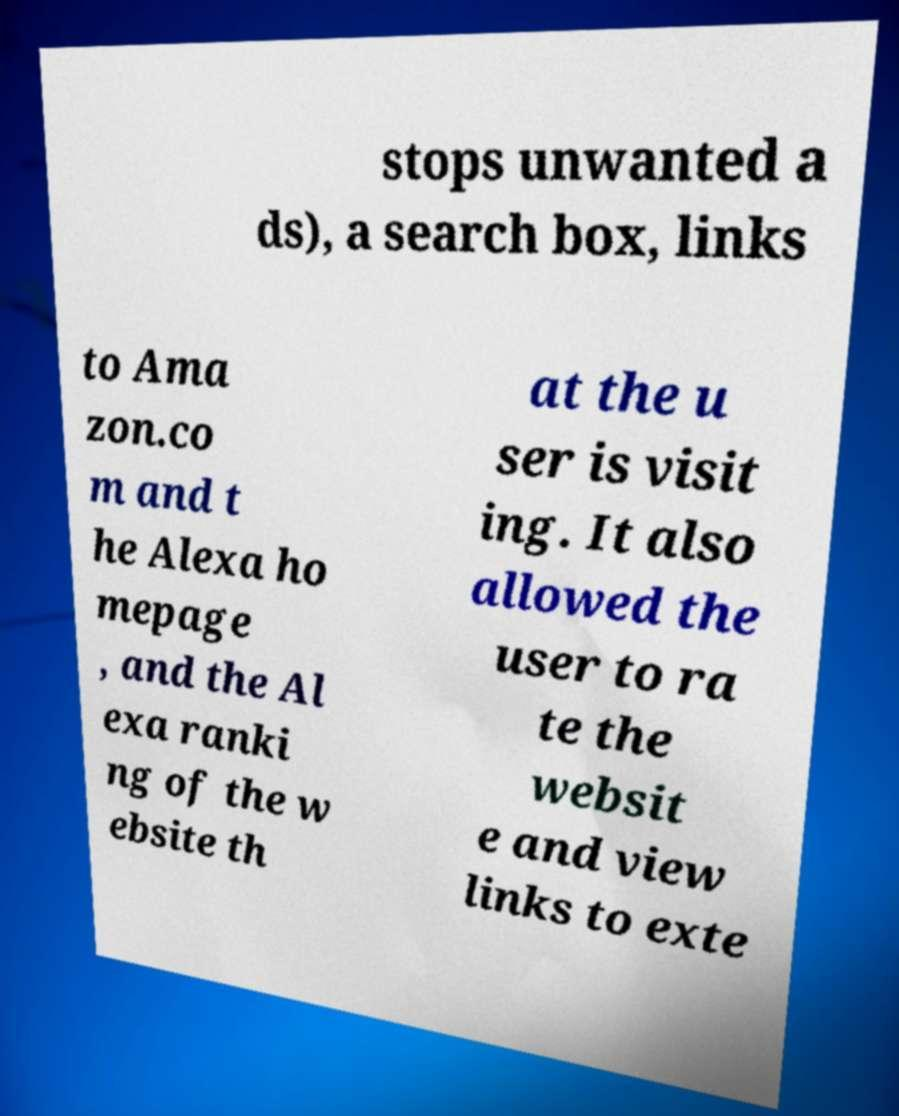For documentation purposes, I need the text within this image transcribed. Could you provide that? stops unwanted a ds), a search box, links to Ama zon.co m and t he Alexa ho mepage , and the Al exa ranki ng of the w ebsite th at the u ser is visit ing. It also allowed the user to ra te the websit e and view links to exte 